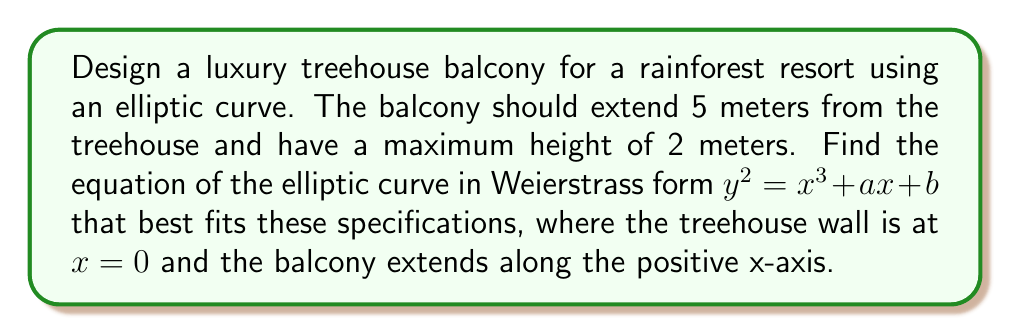Provide a solution to this math problem. 1) An elliptic curve in Weierstrass form is given by $y^2 = x^3 + ax + b$.

2) We need to fit this curve to our specifications:
   - At $x = 0$ (treehouse wall), $y = 0$
   - At $x = 5$ (end of balcony), $y = 0$
   - The maximum height of 2 meters should occur between $x = 0$ and $x = 5$

3) From the first condition, when $x = 0$ and $y = 0$:
   $0^2 = 0^3 + a(0) + b$
   $b = 0$

4) From the second condition, when $x = 5$ and $y = 0$:
   $0^2 = 5^3 + 5a + 0$
   $a = -25$

5) Now our curve equation is $y^2 = x^3 - 25x$

6) To find the maximum height, we differentiate $y$ with respect to $x$:
   $\frac{dy}{dx} = \frac{3x^2 - 25}{2y}$

7) At the maximum point, $\frac{dy}{dx} = 0$, so:
   $3x^2 - 25 = 0$
   $x^2 = \frac{25}{3}$
   $x = \frac{5}{\sqrt{3}} \approx 2.89$

8) The y-coordinate at this point is:
   $y^2 = (\frac{5}{\sqrt{3}})^3 - 25(\frac{5}{\sqrt{3}})$
   $y = 2$

9) This confirms that our maximum height is indeed 2 meters, occurring at $x \approx 2.89$ meters from the treehouse wall.

[asy]
import graph;
size(200,100);
real f(real x) {return sqrt(x^3 - 25x);}
draw(graph(f,0,5),blue);
draw(graph(-f,0,5),blue);
draw((0,0)--(5,0),arrow=Arrow(TeXHead));
draw((0,0)--(0,2),arrow=Arrow(TeXHead));
label("x",((5,0)),SE);
label("y",(0,2),NW);
label("5",(5,0),S);
label("2",(0,2),W);
[/asy]
Answer: $y^2 = x^3 - 25x$ 